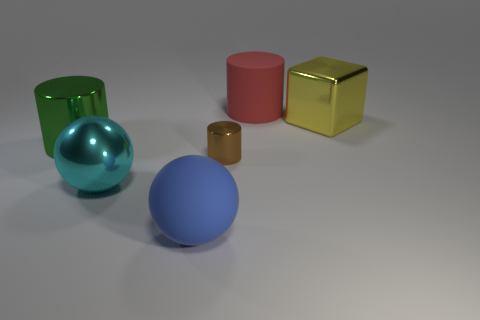Subtract all metal cylinders. How many cylinders are left? 1 Subtract 1 blocks. How many blocks are left? 0 Subtract all purple cubes. How many red cylinders are left? 1 Add 3 red cylinders. How many objects exist? 9 Subtract all brown cylinders. How many cylinders are left? 2 Subtract 0 green cubes. How many objects are left? 6 Subtract all spheres. How many objects are left? 4 Subtract all yellow cylinders. Subtract all purple cubes. How many cylinders are left? 3 Subtract all gray rubber cubes. Subtract all red things. How many objects are left? 5 Add 1 brown shiny things. How many brown shiny things are left? 2 